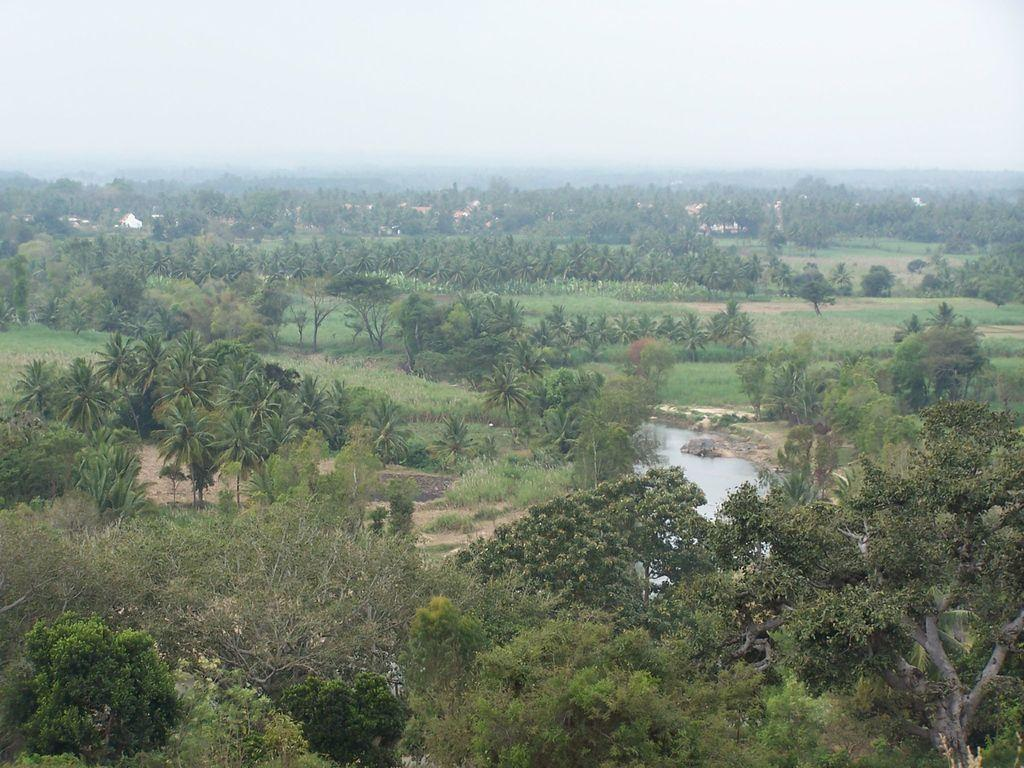What is the main feature of the landscape in the image? There are many trees in the image. What body of water can be seen in the image? There is a canal in the center of the image. What can be seen in the distance in the image? There are hills and fields visible in the background of the image. What is visible above the landscape in the image? The sky is visible in the background of the image. What letters did your dad send you in the image? There are no letters or references to a dad in the image. 